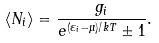<formula> <loc_0><loc_0><loc_500><loc_500>\langle N _ { i } \rangle = { \frac { g _ { i } } { e ^ { ( \varepsilon _ { i } - \mu ) / k T } \pm 1 } } .</formula> 